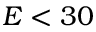Convert formula to latex. <formula><loc_0><loc_0><loc_500><loc_500>E < 3 0</formula> 